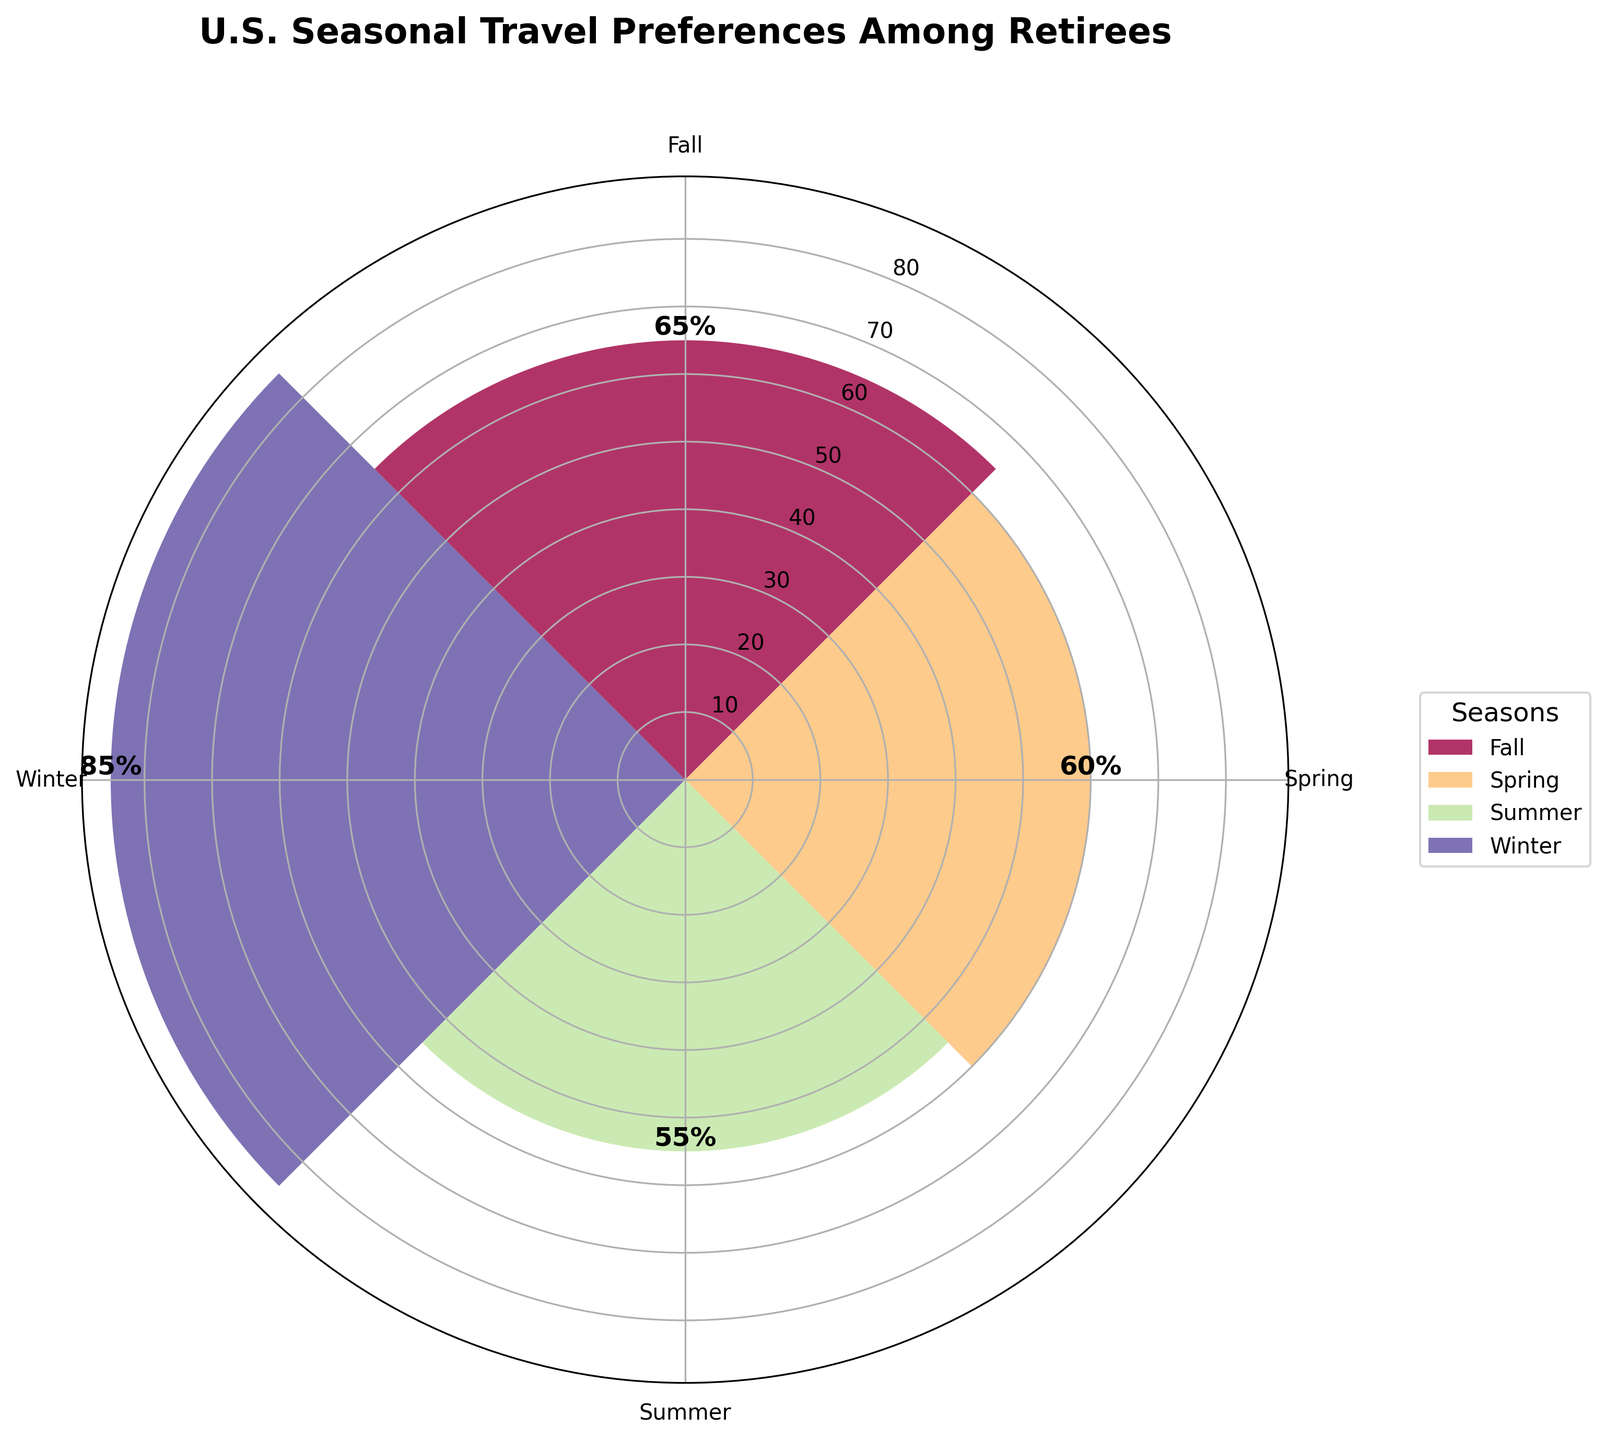Which season has the highest travel frequency among retirees? The plot's labels and bars show that Winter has the highest travel frequency with a value of 85% total.
Answer: Winter What is the total travel frequency for Summer and Fall combined? From the chart, Summer has a travel frequency of 55% and Fall has 65%. Adding these together gives 55 + 65 = 120%.
Answer: 120% Out of the four seasons, which one has the lowest travel frequency? Looking at the chart, Spring has the lowest travel frequency with a value of 60%.
Answer: Spring What is the difference in travel frequency between Fall and Spring? The chart shows Fall with 65% and Spring with 60%. Subtracting these gives 65 - 60 = 5%.
Answer: 5% Which seasons have a travel frequency greater than 60%? The chart indicates that Fall (65%) and Winter (85%) both have travel frequencies greater than 60%.
Answer: Fall, Winter How does the travel frequency in Winter compare to that in Summer? Winter has a travel frequency of 85% and Summer has 55%. Winter is higher by 85 - 55 = 30%.
Answer: Winter is 30% higher What is the average travel frequency for all seasons? Adding the frequencies for all four seasons: 60 + 55 + 65 + 85 = 265. Dividing by 4 gives an average of 265 / 4 = 66.25%.
Answer: 66.25% If you only look at the travel frequencies for Spring and Winter, which one is higher and by how much? Spring has a frequency of 60%, and Winter has 85%. Winter is higher by 85 - 60 = 25%.
Answer: Winter by 25% What proportion of the year's travel frequency does Summer contribute? Total travel frequency is 60 (Spring) + 55 (Summer) + 65 (Fall) + 85 (Winter) = 265. Summer's proportion is 55 / 265 ≈ 20.75%.
Answer: 20.75% Is there any season that has exactly 40% travel frequency? By inspecting the values on the chart, no season has a travel frequency of 40%.
Answer: No 